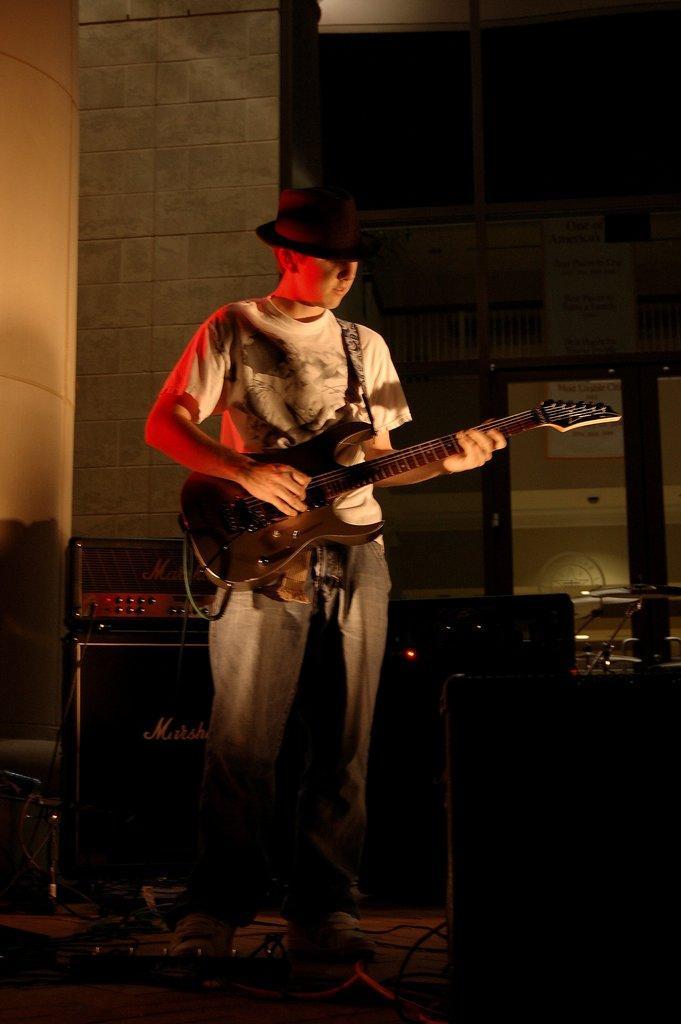Could you give a brief overview of what you see in this image? In this picture we can see man wore cap holding guitar in his hand and playing it and in background we can see table, speakers, wall. 